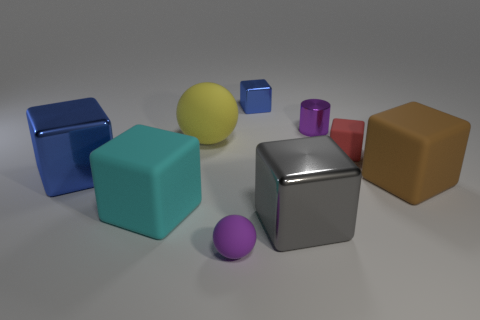Is the yellow rubber thing the same size as the gray object?
Provide a short and direct response. Yes. What number of metal objects are either big gray balls or big yellow spheres?
Make the answer very short. 0. There is a cylinder that is the same size as the red matte thing; what is its material?
Ensure brevity in your answer.  Metal. What number of other objects are there of the same material as the large sphere?
Offer a very short reply. 4. Is the number of rubber balls that are to the left of the large yellow rubber object less than the number of large objects?
Ensure brevity in your answer.  Yes. Do the tiny red matte object and the large blue thing have the same shape?
Ensure brevity in your answer.  Yes. There is a blue metal object that is right of the metal thing to the left of the small cube that is behind the yellow ball; what size is it?
Your answer should be compact. Small. What material is the tiny blue thing that is the same shape as the gray shiny object?
Give a very brief answer. Metal. How big is the blue cube that is behind the big shiny block behind the large brown rubber thing?
Offer a terse response. Small. The tiny metallic block is what color?
Your answer should be very brief. Blue. 